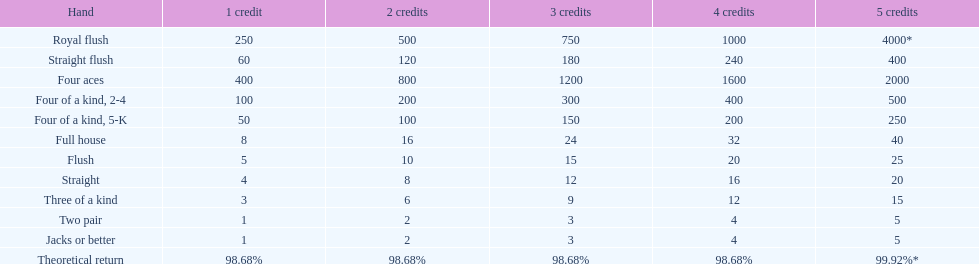With four aces, what is the least amount of credits necessary to reach a payout of 2000 or more? 5 credits. 